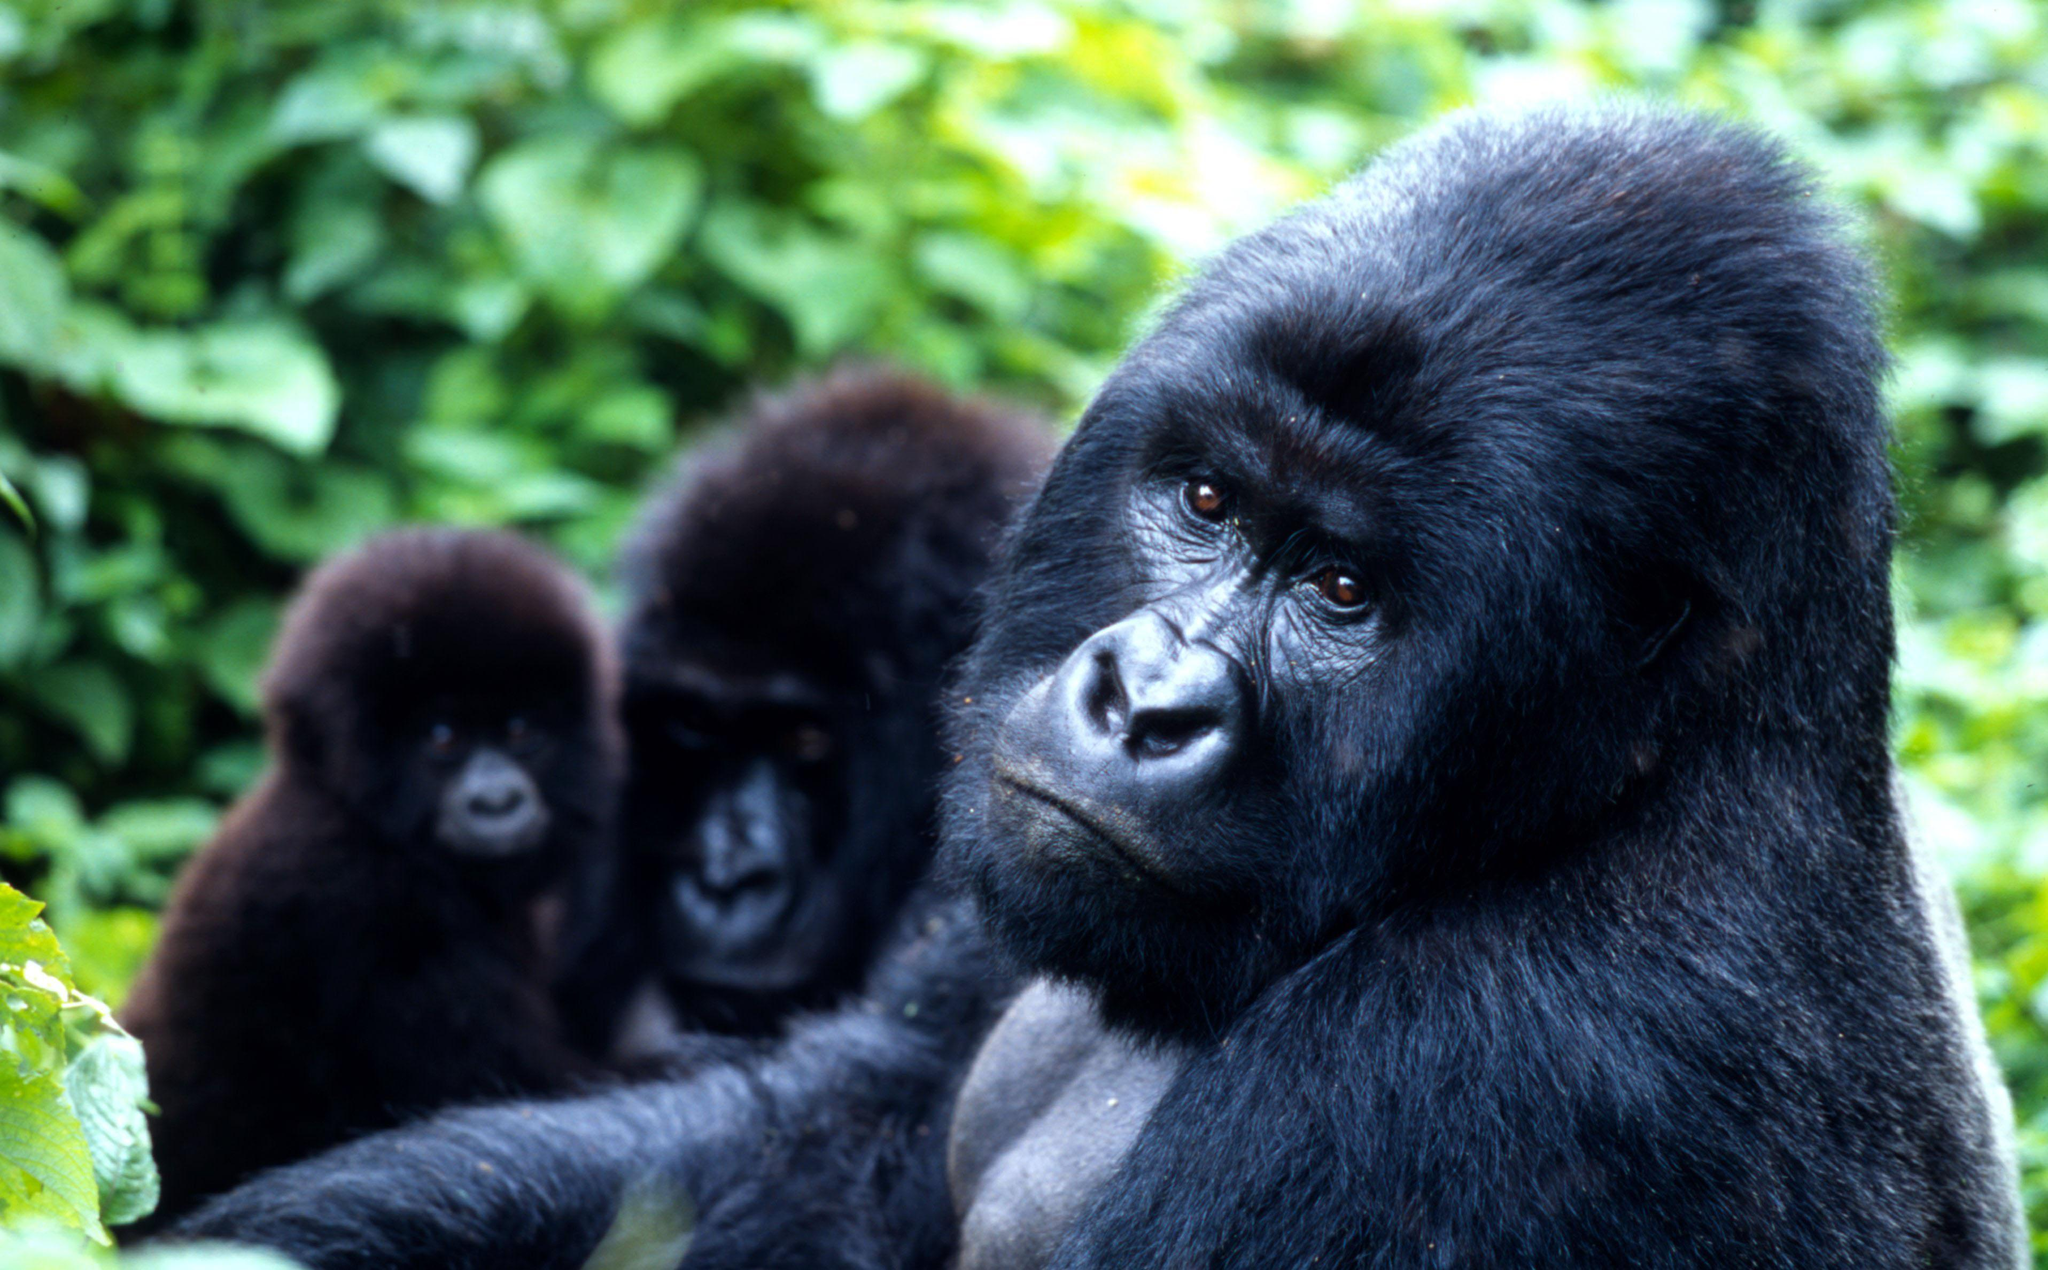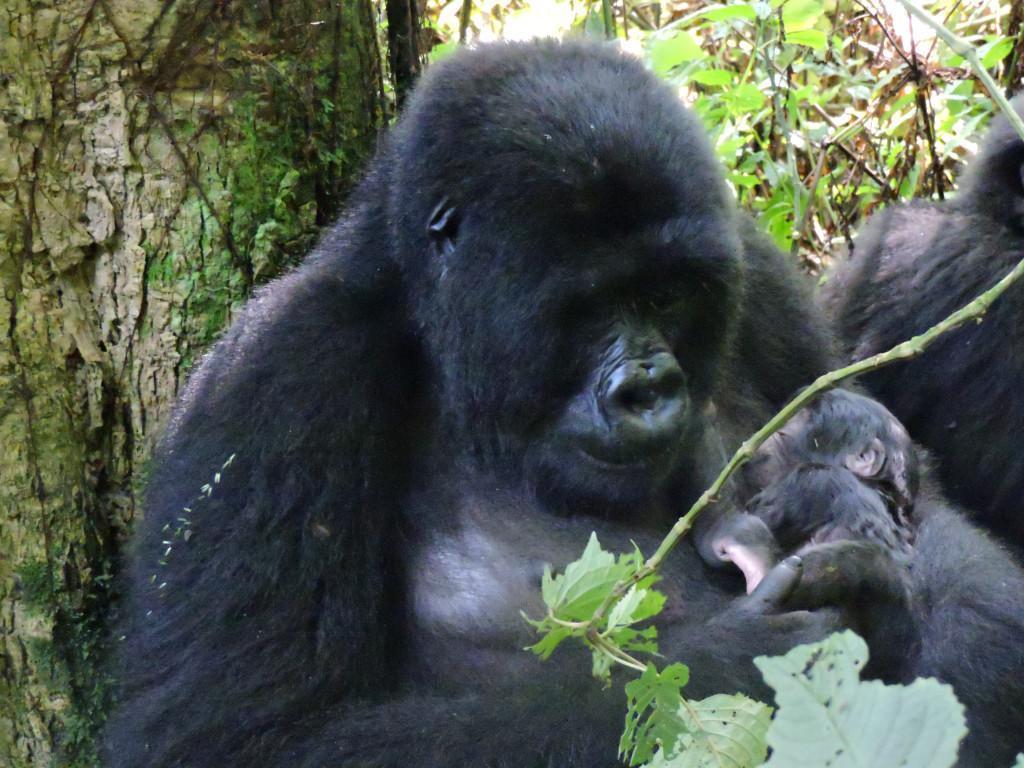The first image is the image on the left, the second image is the image on the right. Given the left and right images, does the statement "There are adult and juvenile gorillas in each image." hold true? Answer yes or no. Yes. 